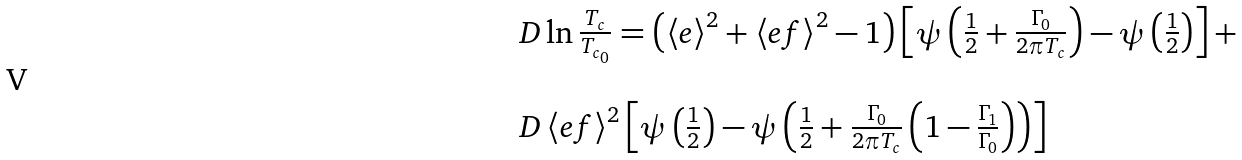<formula> <loc_0><loc_0><loc_500><loc_500>\begin{array} { l } \ D \ln \frac { T _ { c } } { T _ { c _ { 0 } } } = \left ( \left < e \right > ^ { 2 } + \left < e f \right > ^ { 2 } - 1 \right ) \left [ \psi \left ( \frac { 1 } { 2 } + \frac { \Gamma _ { 0 } } { 2 \pi T _ { c } } \right ) - \psi \left ( \frac { 1 } { 2 } \right ) \right ] + \\ \\ \ D \left < e f \right > ^ { 2 } \left [ \psi \left ( \frac { 1 } { 2 } \right ) - \psi \left ( \frac { 1 } { 2 } + \frac { \Gamma _ { 0 } } { 2 \pi T _ { c } } \left ( 1 - \frac { \Gamma _ { 1 } } { \Gamma _ { 0 } } \right ) \right ) \right ] \\ \end{array}</formula> 